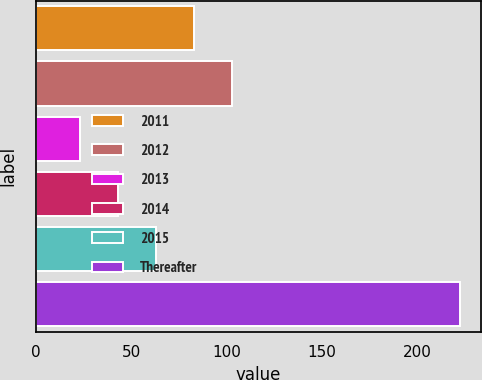Convert chart. <chart><loc_0><loc_0><loc_500><loc_500><bar_chart><fcel>2011<fcel>2012<fcel>2013<fcel>2014<fcel>2015<fcel>Thereafter<nl><fcel>82.7<fcel>102.6<fcel>23<fcel>42.9<fcel>62.8<fcel>222<nl></chart> 